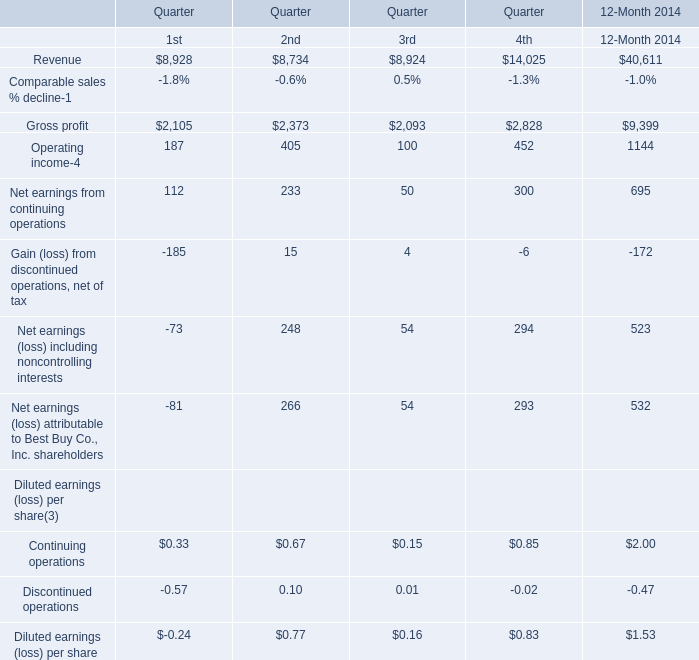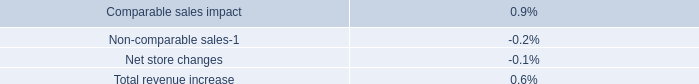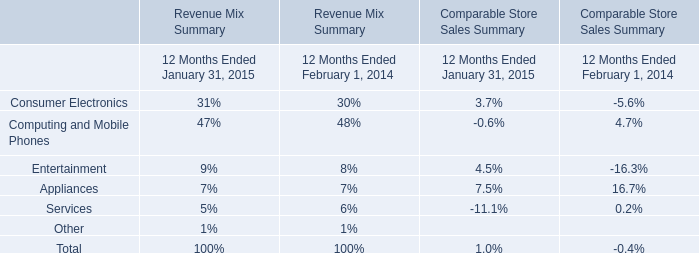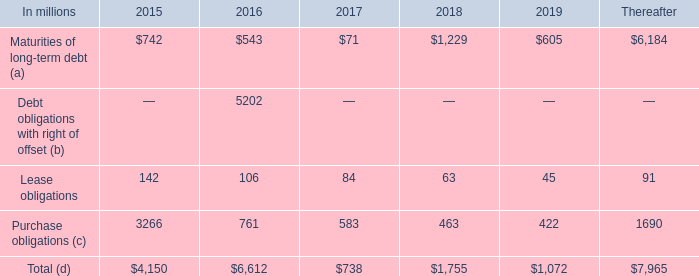in 2014 what was the ratio of the international paper interest in other entities to debt obligation listed in the financial statements 
Computations: (5.2 / 5.3)
Answer: 0.98113. 